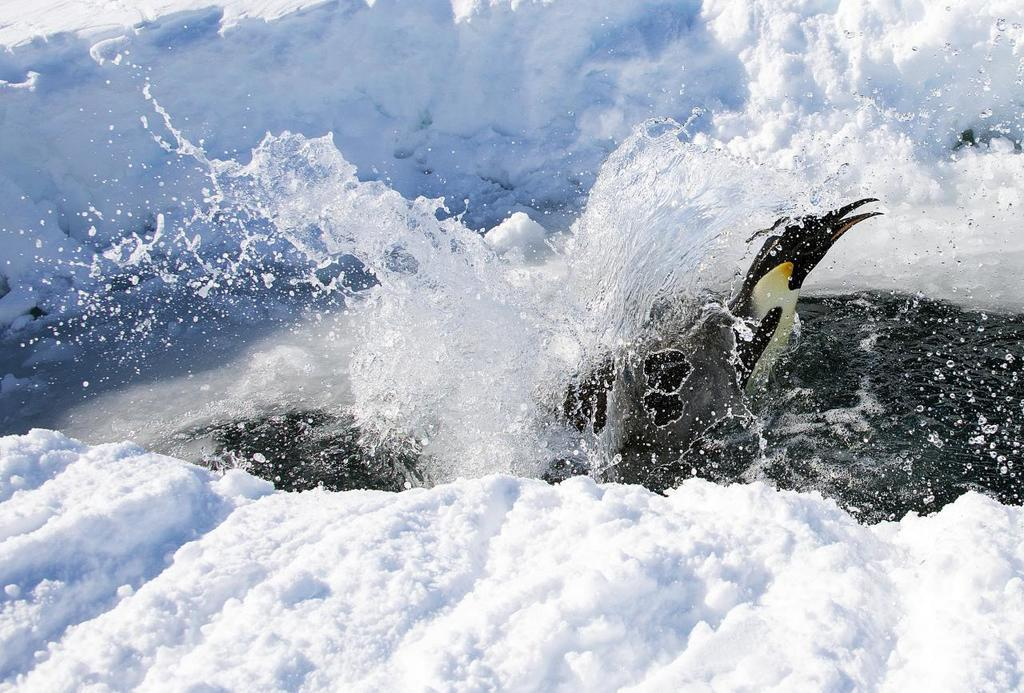What is the main subject of the image? There is a bird in the center of the image. Where is the bird located? The bird is in the water. What type of weather or season is suggested by the image? The presence of snow in the image suggests a cold or wintery environment. What type of mitten is the bird wearing on its hand in the image? There is no mitten or hand visible in the image; the bird is simply in the water. 